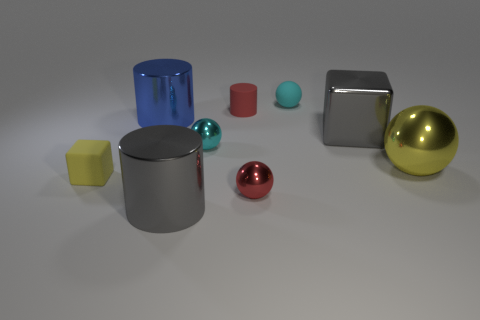What number of shiny blocks are the same color as the matte sphere? Upon carefully observing the image, there are no shiny blocks with the same color as the matte sphere. The two differently textured objects appear clearly distinct in their colors, emphasizing the zero match between the shiny blocks and the matte sphere. 